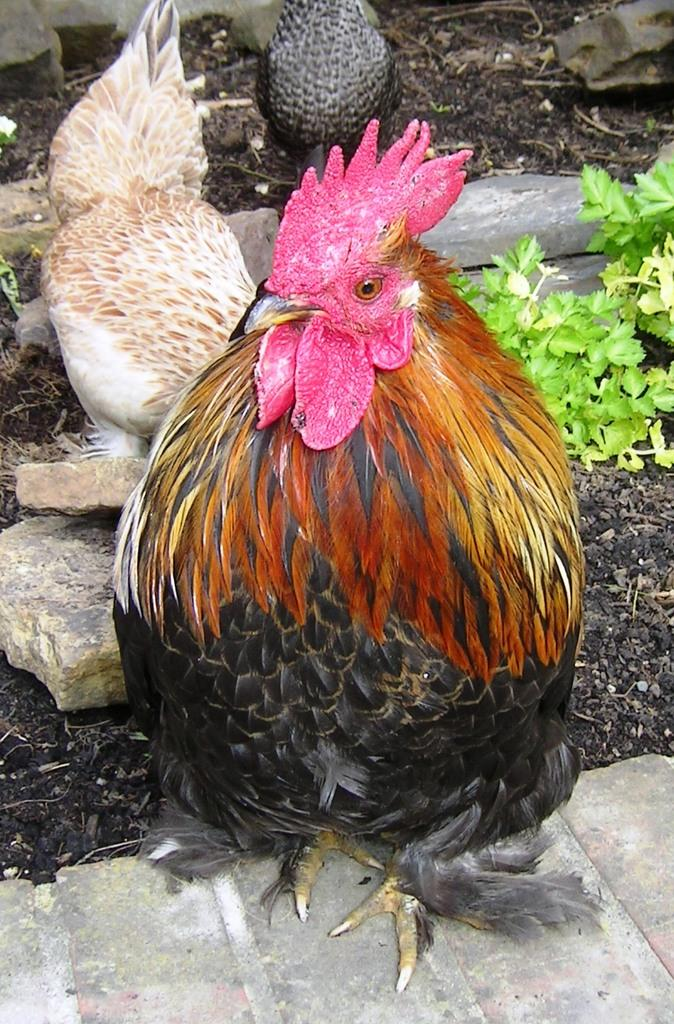What animals can be seen on the ground in the image? There are hens on the ground in the image. What type of natural elements can be seen in the background of the image? Stones and leaves are visible in the background of the image. Can you describe the zebra's side-to-side jumping motion in the image? There is no zebra present in the image, and therefore no jumping motion can be observed. 